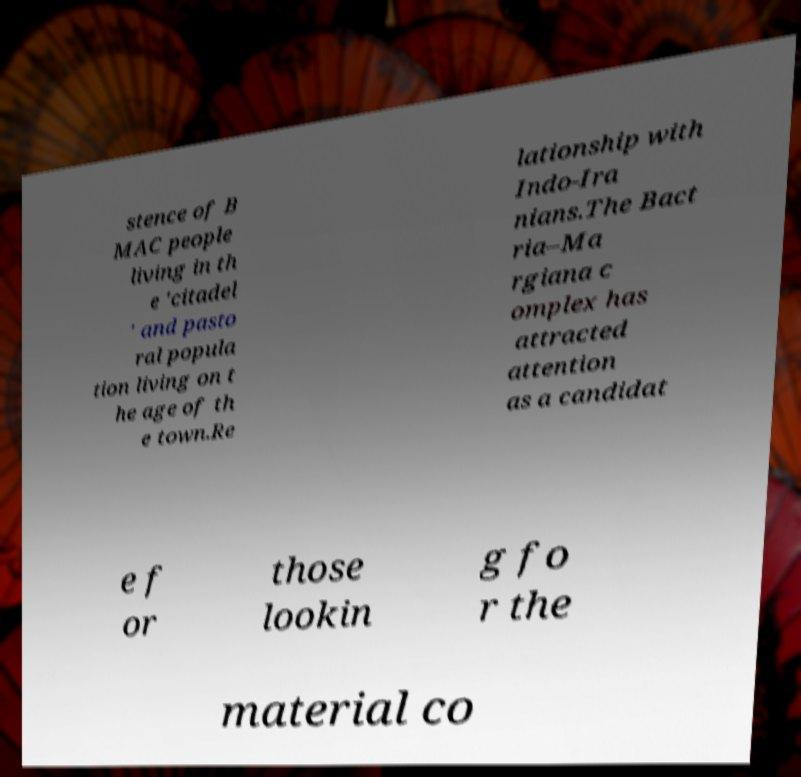Could you assist in decoding the text presented in this image and type it out clearly? stence of B MAC people living in th e 'citadel ' and pasto ral popula tion living on t he age of th e town.Re lationship with Indo-Ira nians.The Bact ria–Ma rgiana c omplex has attracted attention as a candidat e f or those lookin g fo r the material co 